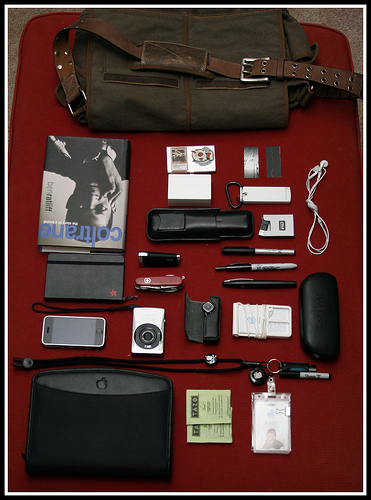<image>
Is there a pen on the book? No. The pen is not positioned on the book. They may be near each other, but the pen is not supported by or resting on top of the book. 